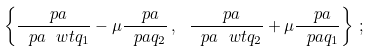<formula> <loc_0><loc_0><loc_500><loc_500>\left \{ \frac { \ p a } { \ p a \ w t { q } _ { 1 } } - \mu \frac { \ p a } { \ p a q _ { 2 } } \, , \ \frac { \ p a } { \ p a \ w t { q } _ { 2 } } + \mu \frac { \ p a } { \ p a q _ { 1 } } \right \} \, ;</formula> 